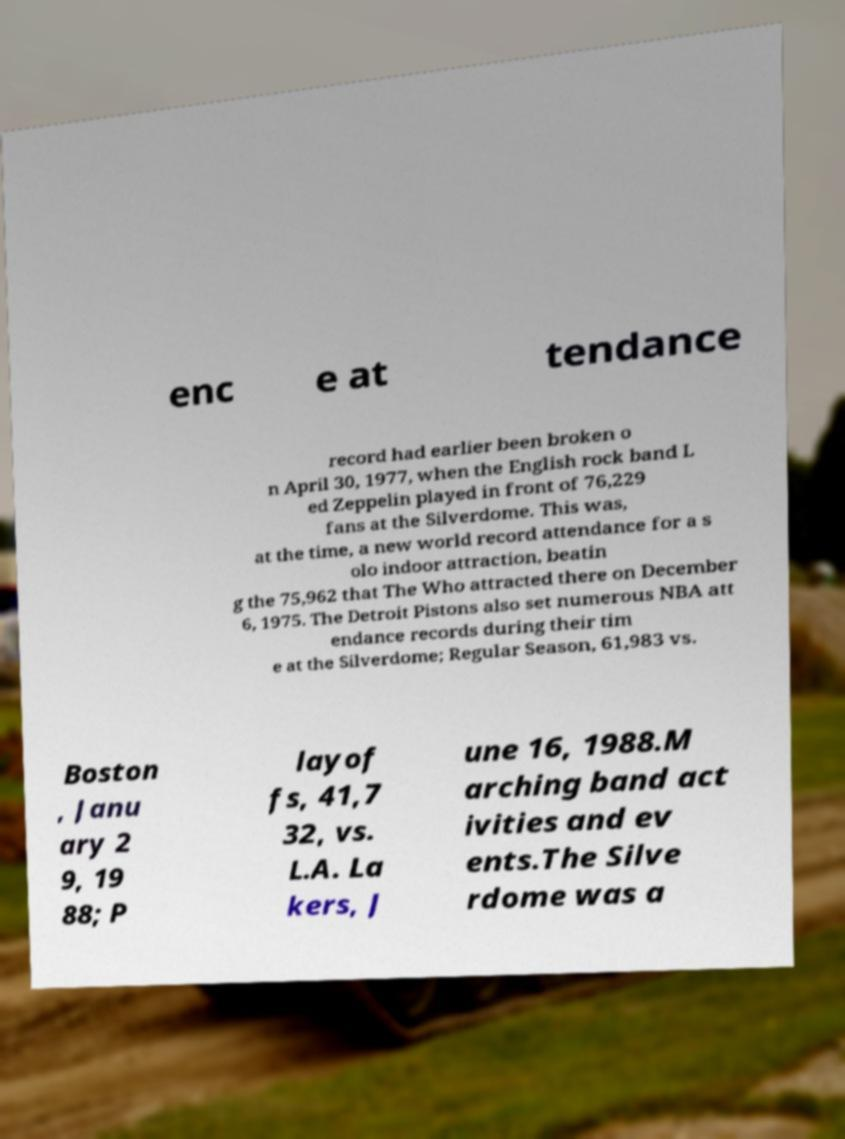Could you extract and type out the text from this image? enc e at tendance record had earlier been broken o n April 30, 1977, when the English rock band L ed Zeppelin played in front of 76,229 fans at the Silverdome. This was, at the time, a new world record attendance for a s olo indoor attraction, beatin g the 75,962 that The Who attracted there on December 6, 1975. The Detroit Pistons also set numerous NBA att endance records during their tim e at the Silverdome; Regular Season, 61,983 vs. Boston , Janu ary 2 9, 19 88; P layof fs, 41,7 32, vs. L.A. La kers, J une 16, 1988.M arching band act ivities and ev ents.The Silve rdome was a 